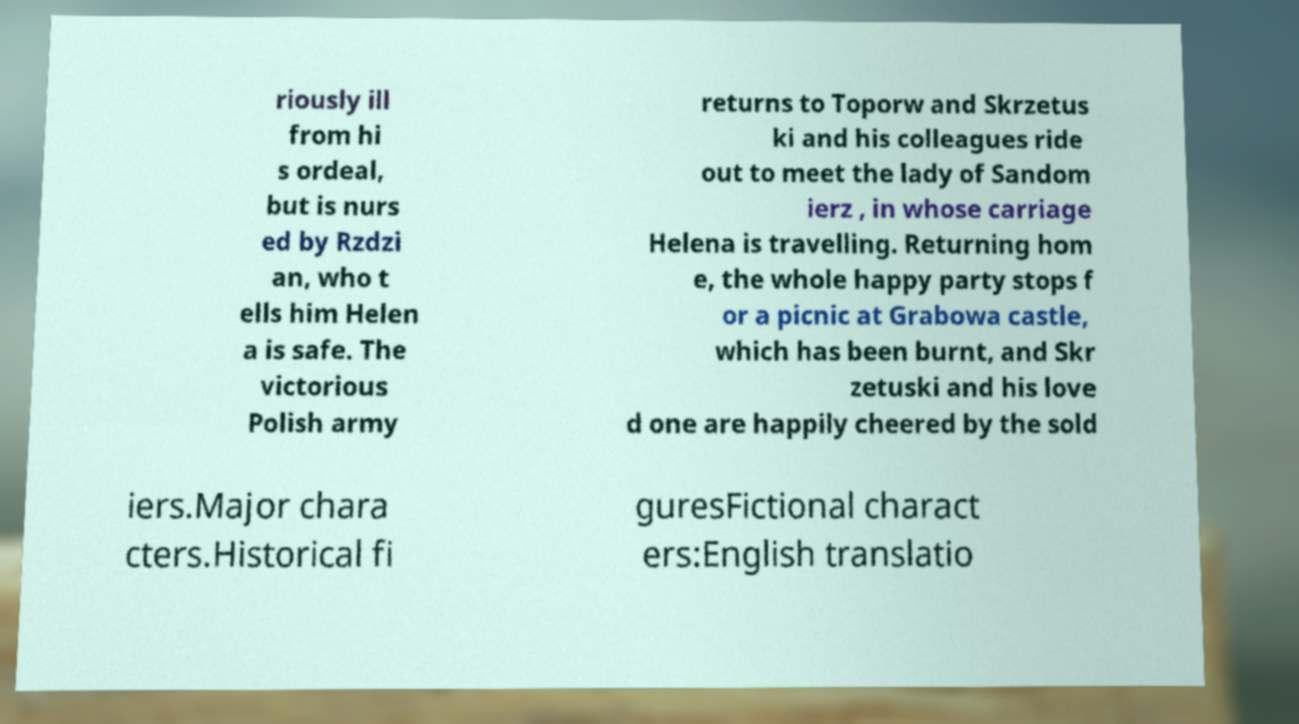Please read and relay the text visible in this image. What does it say? riously ill from hi s ordeal, but is nurs ed by Rzdzi an, who t ells him Helen a is safe. The victorious Polish army returns to Toporw and Skrzetus ki and his colleagues ride out to meet the lady of Sandom ierz , in whose carriage Helena is travelling. Returning hom e, the whole happy party stops f or a picnic at Grabowa castle, which has been burnt, and Skr zetuski and his love d one are happily cheered by the sold iers.Major chara cters.Historical fi guresFictional charact ers:English translatio 